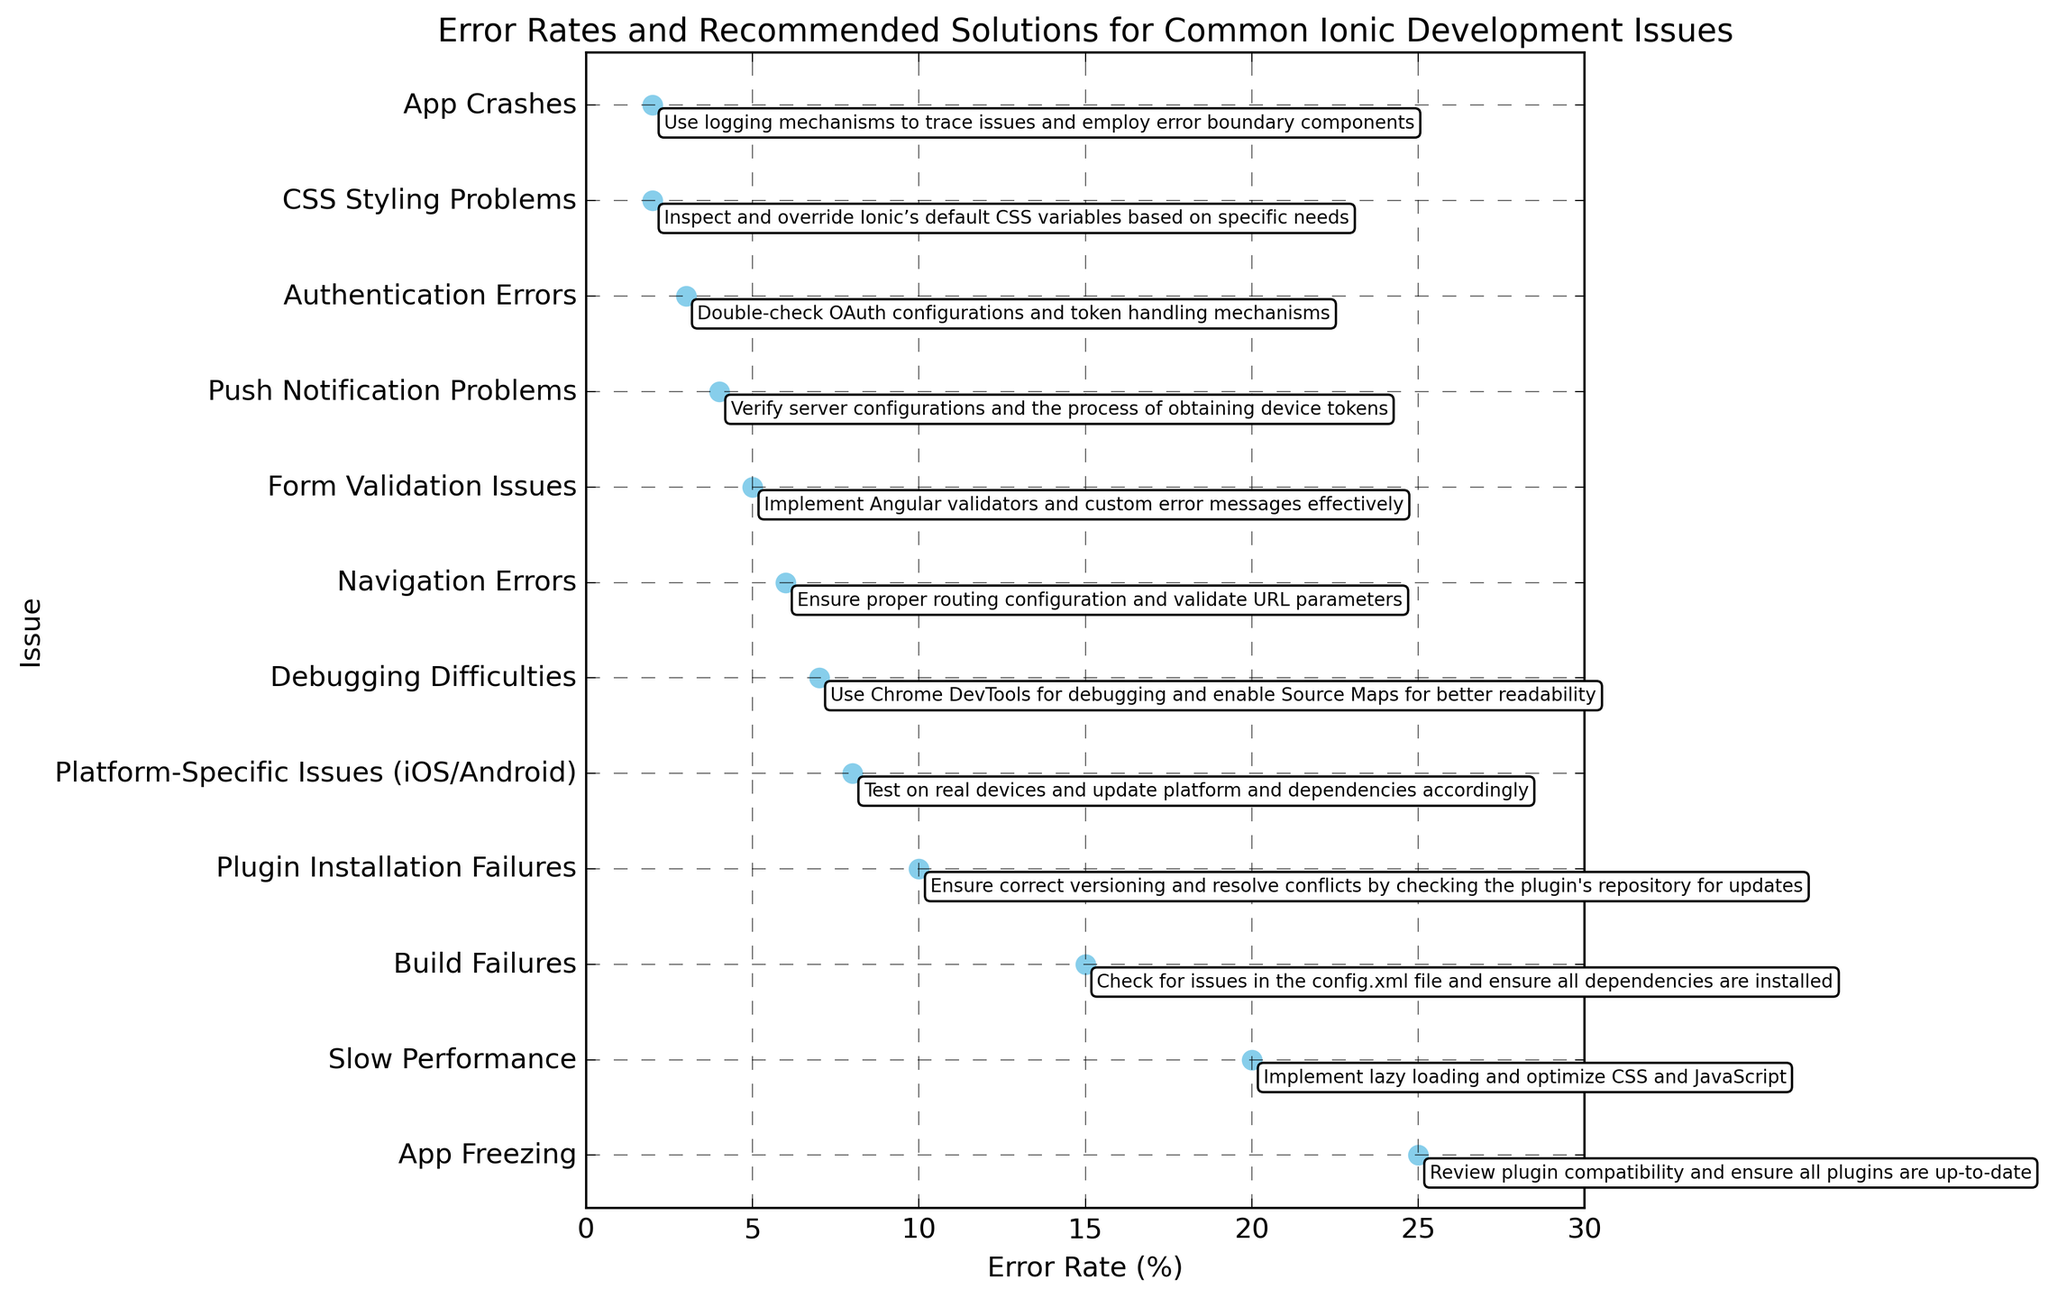What's the highest error rate issue? The 'Error Rate (%)' axis shows the percentage for each issue. 'App Freezing' has the highest error rate at 25%.
Answer: App Freezing What solution is recommended for Build Failures? By finding 'Build Failures' on the 'Issue' axis and referring to the text annotation, the recommended solution is 'Check for issues in the config.xml file and ensure all dependencies are installed'.
Answer: Check for issues in the config.xml file and ensure all dependencies are installed Which issue has a lower error rate: Plugin Installation Failures or Platform-Specific Issues (iOS/Android)? By comparing the error rates on the 'Error Rate (%)' axis, 'Plugin Installation Failures' has an error rate of 10%, and 'Platform-Specific Issues (iOS/Android)' has an error rate of 8%. Thus, Platform-Specific Issues have a lower error rate.
Answer: Platform-Specific Issues (iOS/Android) Which issues have an error rate equal to or less than 5%? By examining the 'Error Rate (%)' axis and locating the bars with 5% or lower, the issues are 'Form Validation Issues' (5%), 'Push Notification Problems' (4%), 'Authentication Errors' (3%), 'CSS Styling Problems' (2%), and 'App Crashes' (2%).
Answer: Form Validation Issues, Push Notification Problems, Authentication Errors, CSS Styling Problems, App Crashes What is the recommended solution for Slow Performance? Referring to the text annotation for 'Slow Performance', the solution is 'Implement lazy loading and optimize CSS and JavaScript'.
Answer: Implement lazy loading and optimize CSS and JavaScript 